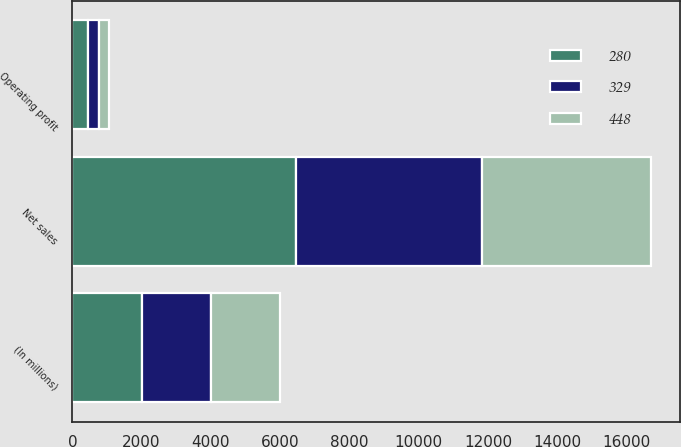<chart> <loc_0><loc_0><loc_500><loc_500><stacked_bar_chart><ecel><fcel>(In millions)<fcel>Net sales<fcel>Operating profit<nl><fcel>280<fcel>2002<fcel>6471<fcel>448<nl><fcel>329<fcel>2001<fcel>5355<fcel>329<nl><fcel>448<fcel>2000<fcel>4885<fcel>280<nl></chart> 